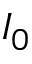<formula> <loc_0><loc_0><loc_500><loc_500>I _ { 0 }</formula> 